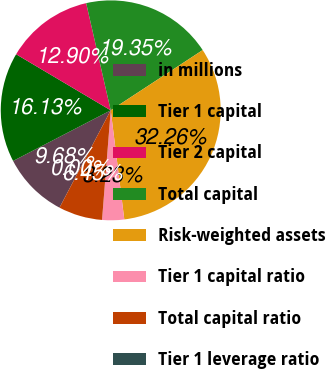<chart> <loc_0><loc_0><loc_500><loc_500><pie_chart><fcel>in millions<fcel>Tier 1 capital<fcel>Tier 2 capital<fcel>Total capital<fcel>Risk-weighted assets<fcel>Tier 1 capital ratio<fcel>Total capital ratio<fcel>Tier 1 leverage ratio<nl><fcel>9.68%<fcel>16.13%<fcel>12.9%<fcel>19.35%<fcel>32.26%<fcel>3.23%<fcel>6.45%<fcel>0.0%<nl></chart> 